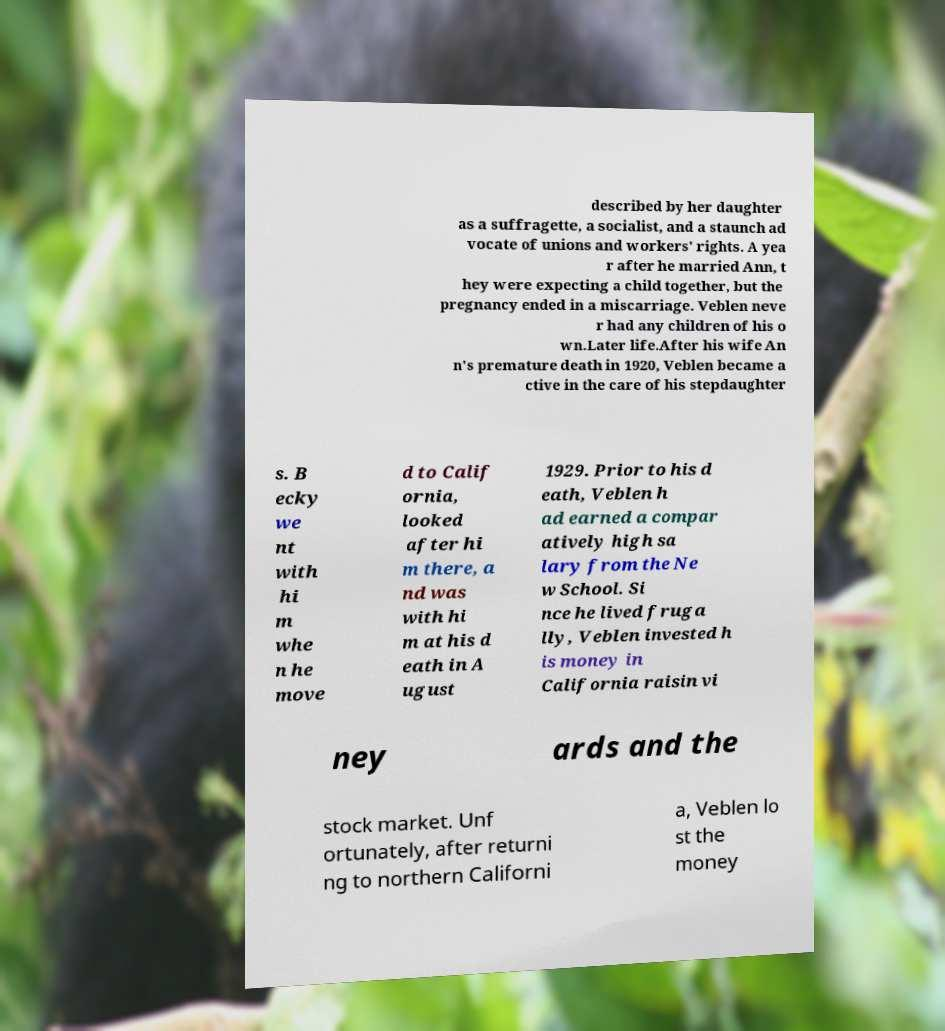Can you read and provide the text displayed in the image?This photo seems to have some interesting text. Can you extract and type it out for me? described by her daughter as a suffragette, a socialist, and a staunch ad vocate of unions and workers' rights. A yea r after he married Ann, t hey were expecting a child together, but the pregnancy ended in a miscarriage. Veblen neve r had any children of his o wn.Later life.After his wife An n's premature death in 1920, Veblen became a ctive in the care of his stepdaughter s. B ecky we nt with hi m whe n he move d to Calif ornia, looked after hi m there, a nd was with hi m at his d eath in A ugust 1929. Prior to his d eath, Veblen h ad earned a compar atively high sa lary from the Ne w School. Si nce he lived fruga lly, Veblen invested h is money in California raisin vi ney ards and the stock market. Unf ortunately, after returni ng to northern Californi a, Veblen lo st the money 